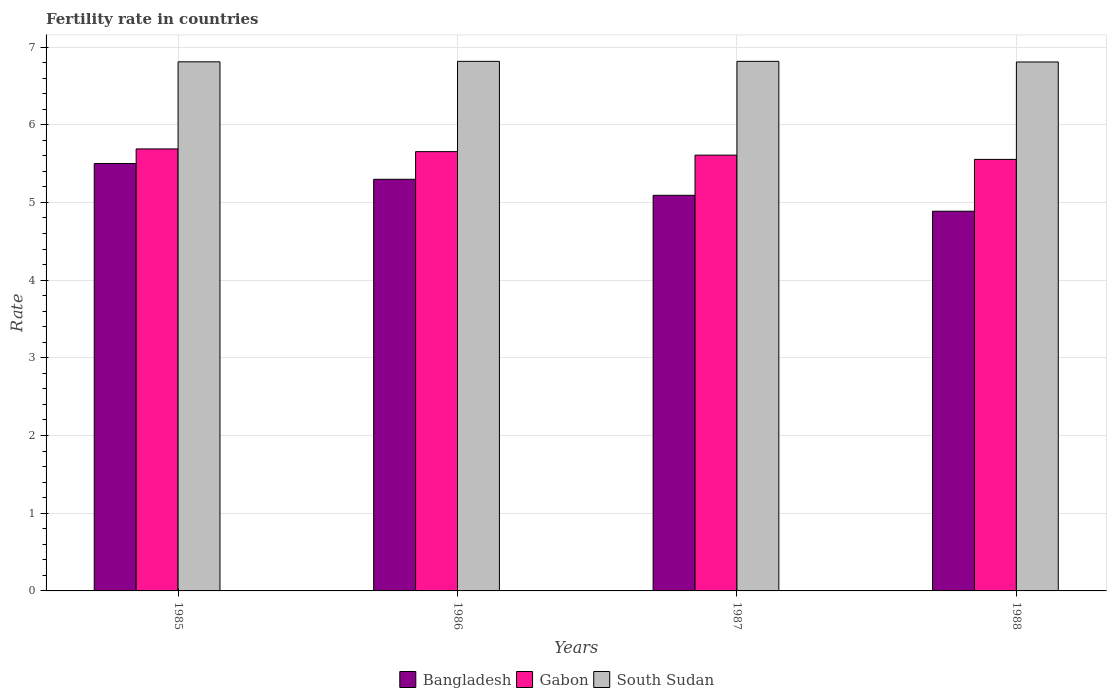How many different coloured bars are there?
Your response must be concise. 3. How many bars are there on the 3rd tick from the left?
Your answer should be compact. 3. In how many cases, is the number of bars for a given year not equal to the number of legend labels?
Your answer should be compact. 0. What is the fertility rate in Bangladesh in 1986?
Offer a very short reply. 5.3. Across all years, what is the maximum fertility rate in Gabon?
Your answer should be very brief. 5.69. Across all years, what is the minimum fertility rate in Gabon?
Your answer should be very brief. 5.55. In which year was the fertility rate in Bangladesh maximum?
Your response must be concise. 1985. What is the total fertility rate in Gabon in the graph?
Your answer should be compact. 22.51. What is the difference between the fertility rate in Bangladesh in 1985 and that in 1987?
Your response must be concise. 0.41. What is the difference between the fertility rate in Gabon in 1986 and the fertility rate in Bangladesh in 1985?
Give a very brief answer. 0.15. What is the average fertility rate in South Sudan per year?
Make the answer very short. 6.81. In the year 1985, what is the difference between the fertility rate in Gabon and fertility rate in South Sudan?
Offer a very short reply. -1.12. In how many years, is the fertility rate in South Sudan greater than 5.8?
Provide a succinct answer. 4. What is the ratio of the fertility rate in Gabon in 1985 to that in 1987?
Your answer should be very brief. 1.01. Is the fertility rate in Gabon in 1985 less than that in 1986?
Give a very brief answer. No. What is the difference between the highest and the second highest fertility rate in Gabon?
Make the answer very short. 0.04. What is the difference between the highest and the lowest fertility rate in Bangladesh?
Your response must be concise. 0.61. What does the 3rd bar from the left in 1986 represents?
Provide a succinct answer. South Sudan. What does the 1st bar from the right in 1985 represents?
Keep it short and to the point. South Sudan. How many bars are there?
Offer a terse response. 12. Are all the bars in the graph horizontal?
Keep it short and to the point. No. Are the values on the major ticks of Y-axis written in scientific E-notation?
Offer a very short reply. No. Does the graph contain grids?
Provide a succinct answer. Yes. Where does the legend appear in the graph?
Provide a succinct answer. Bottom center. How many legend labels are there?
Your response must be concise. 3. How are the legend labels stacked?
Ensure brevity in your answer.  Horizontal. What is the title of the graph?
Offer a terse response. Fertility rate in countries. What is the label or title of the X-axis?
Keep it short and to the point. Years. What is the label or title of the Y-axis?
Give a very brief answer. Rate. What is the Rate in Bangladesh in 1985?
Your answer should be very brief. 5.5. What is the Rate of Gabon in 1985?
Provide a succinct answer. 5.69. What is the Rate in South Sudan in 1985?
Make the answer very short. 6.81. What is the Rate of Bangladesh in 1986?
Make the answer very short. 5.3. What is the Rate of Gabon in 1986?
Offer a very short reply. 5.65. What is the Rate of South Sudan in 1986?
Provide a succinct answer. 6.82. What is the Rate in Bangladesh in 1987?
Offer a very short reply. 5.09. What is the Rate of Gabon in 1987?
Ensure brevity in your answer.  5.61. What is the Rate in South Sudan in 1987?
Your response must be concise. 6.82. What is the Rate of Bangladesh in 1988?
Your response must be concise. 4.89. What is the Rate of Gabon in 1988?
Offer a terse response. 5.55. What is the Rate in South Sudan in 1988?
Offer a terse response. 6.81. Across all years, what is the maximum Rate in Bangladesh?
Your answer should be compact. 5.5. Across all years, what is the maximum Rate in Gabon?
Your response must be concise. 5.69. Across all years, what is the maximum Rate in South Sudan?
Make the answer very short. 6.82. Across all years, what is the minimum Rate in Bangladesh?
Ensure brevity in your answer.  4.89. Across all years, what is the minimum Rate in Gabon?
Provide a short and direct response. 5.55. Across all years, what is the minimum Rate of South Sudan?
Keep it short and to the point. 6.81. What is the total Rate of Bangladesh in the graph?
Your response must be concise. 20.78. What is the total Rate in Gabon in the graph?
Your answer should be very brief. 22.51. What is the total Rate in South Sudan in the graph?
Ensure brevity in your answer.  27.25. What is the difference between the Rate of Bangladesh in 1985 and that in 1986?
Your response must be concise. 0.2. What is the difference between the Rate in Gabon in 1985 and that in 1986?
Keep it short and to the point. 0.04. What is the difference between the Rate in South Sudan in 1985 and that in 1986?
Offer a very short reply. -0.01. What is the difference between the Rate in Bangladesh in 1985 and that in 1987?
Your response must be concise. 0.41. What is the difference between the Rate in South Sudan in 1985 and that in 1987?
Make the answer very short. -0.01. What is the difference between the Rate of Bangladesh in 1985 and that in 1988?
Make the answer very short. 0.61. What is the difference between the Rate in Gabon in 1985 and that in 1988?
Ensure brevity in your answer.  0.14. What is the difference between the Rate of South Sudan in 1985 and that in 1988?
Your response must be concise. 0. What is the difference between the Rate of Bangladesh in 1986 and that in 1987?
Offer a very short reply. 0.21. What is the difference between the Rate of Gabon in 1986 and that in 1987?
Ensure brevity in your answer.  0.04. What is the difference between the Rate in South Sudan in 1986 and that in 1987?
Make the answer very short. 0. What is the difference between the Rate in Bangladesh in 1986 and that in 1988?
Your answer should be very brief. 0.41. What is the difference between the Rate in Gabon in 1986 and that in 1988?
Give a very brief answer. 0.1. What is the difference between the Rate in South Sudan in 1986 and that in 1988?
Give a very brief answer. 0.01. What is the difference between the Rate in Bangladesh in 1987 and that in 1988?
Your answer should be compact. 0.2. What is the difference between the Rate in Gabon in 1987 and that in 1988?
Provide a short and direct response. 0.06. What is the difference between the Rate of South Sudan in 1987 and that in 1988?
Your answer should be very brief. 0.01. What is the difference between the Rate of Bangladesh in 1985 and the Rate of Gabon in 1986?
Offer a very short reply. -0.15. What is the difference between the Rate of Bangladesh in 1985 and the Rate of South Sudan in 1986?
Your answer should be compact. -1.31. What is the difference between the Rate of Gabon in 1985 and the Rate of South Sudan in 1986?
Your response must be concise. -1.13. What is the difference between the Rate of Bangladesh in 1985 and the Rate of Gabon in 1987?
Provide a short and direct response. -0.11. What is the difference between the Rate in Bangladesh in 1985 and the Rate in South Sudan in 1987?
Give a very brief answer. -1.31. What is the difference between the Rate in Gabon in 1985 and the Rate in South Sudan in 1987?
Keep it short and to the point. -1.13. What is the difference between the Rate of Bangladesh in 1985 and the Rate of Gabon in 1988?
Ensure brevity in your answer.  -0.05. What is the difference between the Rate of Bangladesh in 1985 and the Rate of South Sudan in 1988?
Your answer should be very brief. -1.31. What is the difference between the Rate in Gabon in 1985 and the Rate in South Sudan in 1988?
Ensure brevity in your answer.  -1.12. What is the difference between the Rate in Bangladesh in 1986 and the Rate in Gabon in 1987?
Ensure brevity in your answer.  -0.31. What is the difference between the Rate in Bangladesh in 1986 and the Rate in South Sudan in 1987?
Your answer should be very brief. -1.52. What is the difference between the Rate in Gabon in 1986 and the Rate in South Sudan in 1987?
Keep it short and to the point. -1.16. What is the difference between the Rate in Bangladesh in 1986 and the Rate in Gabon in 1988?
Your answer should be compact. -0.26. What is the difference between the Rate in Bangladesh in 1986 and the Rate in South Sudan in 1988?
Ensure brevity in your answer.  -1.51. What is the difference between the Rate of Gabon in 1986 and the Rate of South Sudan in 1988?
Make the answer very short. -1.15. What is the difference between the Rate in Bangladesh in 1987 and the Rate in Gabon in 1988?
Make the answer very short. -0.46. What is the difference between the Rate of Bangladesh in 1987 and the Rate of South Sudan in 1988?
Provide a short and direct response. -1.72. What is the difference between the Rate in Gabon in 1987 and the Rate in South Sudan in 1988?
Provide a succinct answer. -1.2. What is the average Rate in Bangladesh per year?
Your response must be concise. 5.19. What is the average Rate in Gabon per year?
Make the answer very short. 5.63. What is the average Rate of South Sudan per year?
Make the answer very short. 6.81. In the year 1985, what is the difference between the Rate in Bangladesh and Rate in Gabon?
Provide a succinct answer. -0.19. In the year 1985, what is the difference between the Rate of Bangladesh and Rate of South Sudan?
Provide a short and direct response. -1.31. In the year 1985, what is the difference between the Rate of Gabon and Rate of South Sudan?
Provide a short and direct response. -1.12. In the year 1986, what is the difference between the Rate in Bangladesh and Rate in Gabon?
Give a very brief answer. -0.36. In the year 1986, what is the difference between the Rate in Bangladesh and Rate in South Sudan?
Your response must be concise. -1.52. In the year 1986, what is the difference between the Rate in Gabon and Rate in South Sudan?
Give a very brief answer. -1.16. In the year 1987, what is the difference between the Rate of Bangladesh and Rate of Gabon?
Your response must be concise. -0.52. In the year 1987, what is the difference between the Rate of Bangladesh and Rate of South Sudan?
Provide a succinct answer. -1.72. In the year 1987, what is the difference between the Rate of Gabon and Rate of South Sudan?
Offer a very short reply. -1.21. In the year 1988, what is the difference between the Rate of Bangladesh and Rate of Gabon?
Your answer should be compact. -0.67. In the year 1988, what is the difference between the Rate of Bangladesh and Rate of South Sudan?
Your answer should be compact. -1.92. In the year 1988, what is the difference between the Rate of Gabon and Rate of South Sudan?
Keep it short and to the point. -1.25. What is the ratio of the Rate in Bangladesh in 1985 to that in 1986?
Offer a very short reply. 1.04. What is the ratio of the Rate in Gabon in 1985 to that in 1986?
Provide a succinct answer. 1.01. What is the ratio of the Rate in South Sudan in 1985 to that in 1986?
Provide a succinct answer. 1. What is the ratio of the Rate of Bangladesh in 1985 to that in 1987?
Ensure brevity in your answer.  1.08. What is the ratio of the Rate of Gabon in 1985 to that in 1987?
Your answer should be very brief. 1.01. What is the ratio of the Rate in Bangladesh in 1985 to that in 1988?
Keep it short and to the point. 1.13. What is the ratio of the Rate in Gabon in 1985 to that in 1988?
Offer a terse response. 1.02. What is the ratio of the Rate of Bangladesh in 1986 to that in 1987?
Offer a very short reply. 1.04. What is the ratio of the Rate in Gabon in 1986 to that in 1987?
Give a very brief answer. 1.01. What is the ratio of the Rate in Bangladesh in 1986 to that in 1988?
Offer a terse response. 1.08. What is the ratio of the Rate in Bangladesh in 1987 to that in 1988?
Your answer should be compact. 1.04. What is the ratio of the Rate of Gabon in 1987 to that in 1988?
Keep it short and to the point. 1.01. What is the ratio of the Rate of South Sudan in 1987 to that in 1988?
Offer a terse response. 1. What is the difference between the highest and the second highest Rate of Bangladesh?
Offer a very short reply. 0.2. What is the difference between the highest and the second highest Rate in Gabon?
Make the answer very short. 0.04. What is the difference between the highest and the lowest Rate of Bangladesh?
Ensure brevity in your answer.  0.61. What is the difference between the highest and the lowest Rate of Gabon?
Offer a very short reply. 0.14. What is the difference between the highest and the lowest Rate in South Sudan?
Make the answer very short. 0.01. 